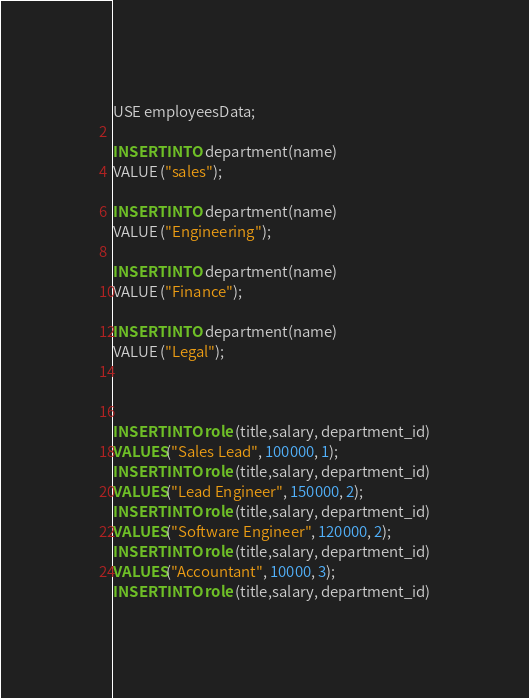<code> <loc_0><loc_0><loc_500><loc_500><_SQL_>USE employeesData;

INSERT INTO department(name)
VALUE ("sales");

INSERT INTO department(name)
VALUE ("Engineering");

INSERT INTO department(name)
VALUE ("Finance");

INSERT INTO department(name)
VALUE ("Legal");



INSERT INTO role (title,salary, department_id)
VALUES("Sales Lead", 100000, 1);
INSERT INTO role (title,salary, department_id)
VALUES("Lead Engineer", 150000, 2);
INSERT INTO role (title,salary, department_id)
VALUES("Software Engineer", 120000, 2);
INSERT INTO role (title,salary, department_id)
VALUES("Accountant", 10000, 3);
INSERT INTO role (title,salary, department_id)</code> 